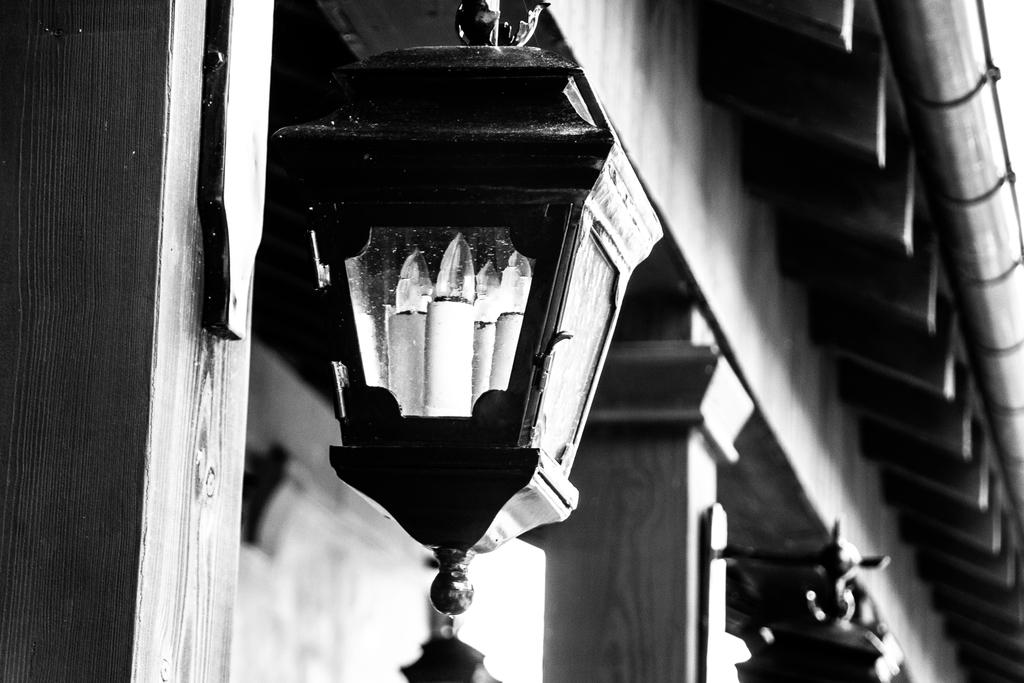What is the color scheme of the image? The image is black and white. What can be seen in the image that provides light? There is a light in the image. What architectural features are present in the image? There are pillars in the image. What is visible above the scene in the image? There is a ceiling visible in the image. What type of background is present in the image? There is a wall in the background of the image. What type of rake is being used to clean the ceiling in the image? There is no rake present in the image, and the ceiling is not being cleaned. 